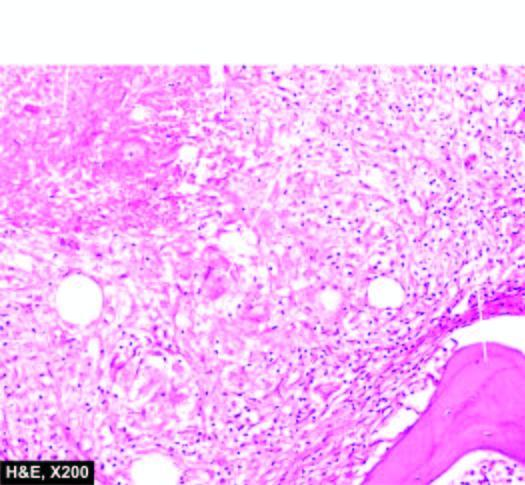re there epithelioid cell granulomas with minute areas of caseation necrosis and surrounded by langhans ' giant cells?
Answer the question using a single word or phrase. Yes 